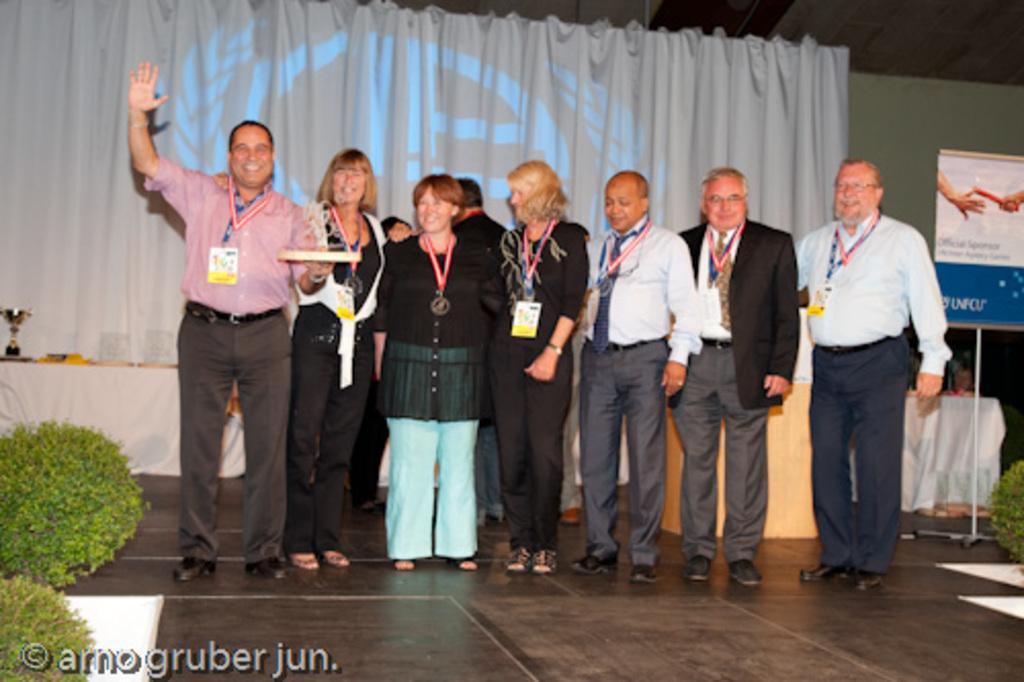How would you summarize this image in a sentence or two? In this image I can see few people standing and these people are wearing the different color dresses and also identification cards. To the side I can see the plants. To the right I can see the board. In the background there is a table and trophy on it. I can also see the curtain in the back. 